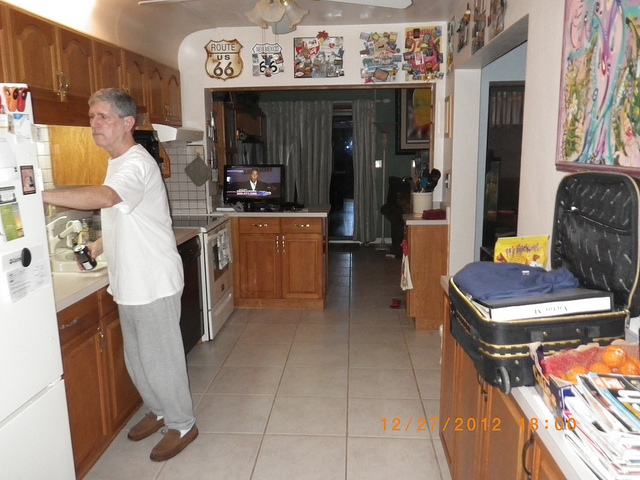Read and extract the text from this image. 2012 ROUTE US 66 65 00 1 8 27 12 